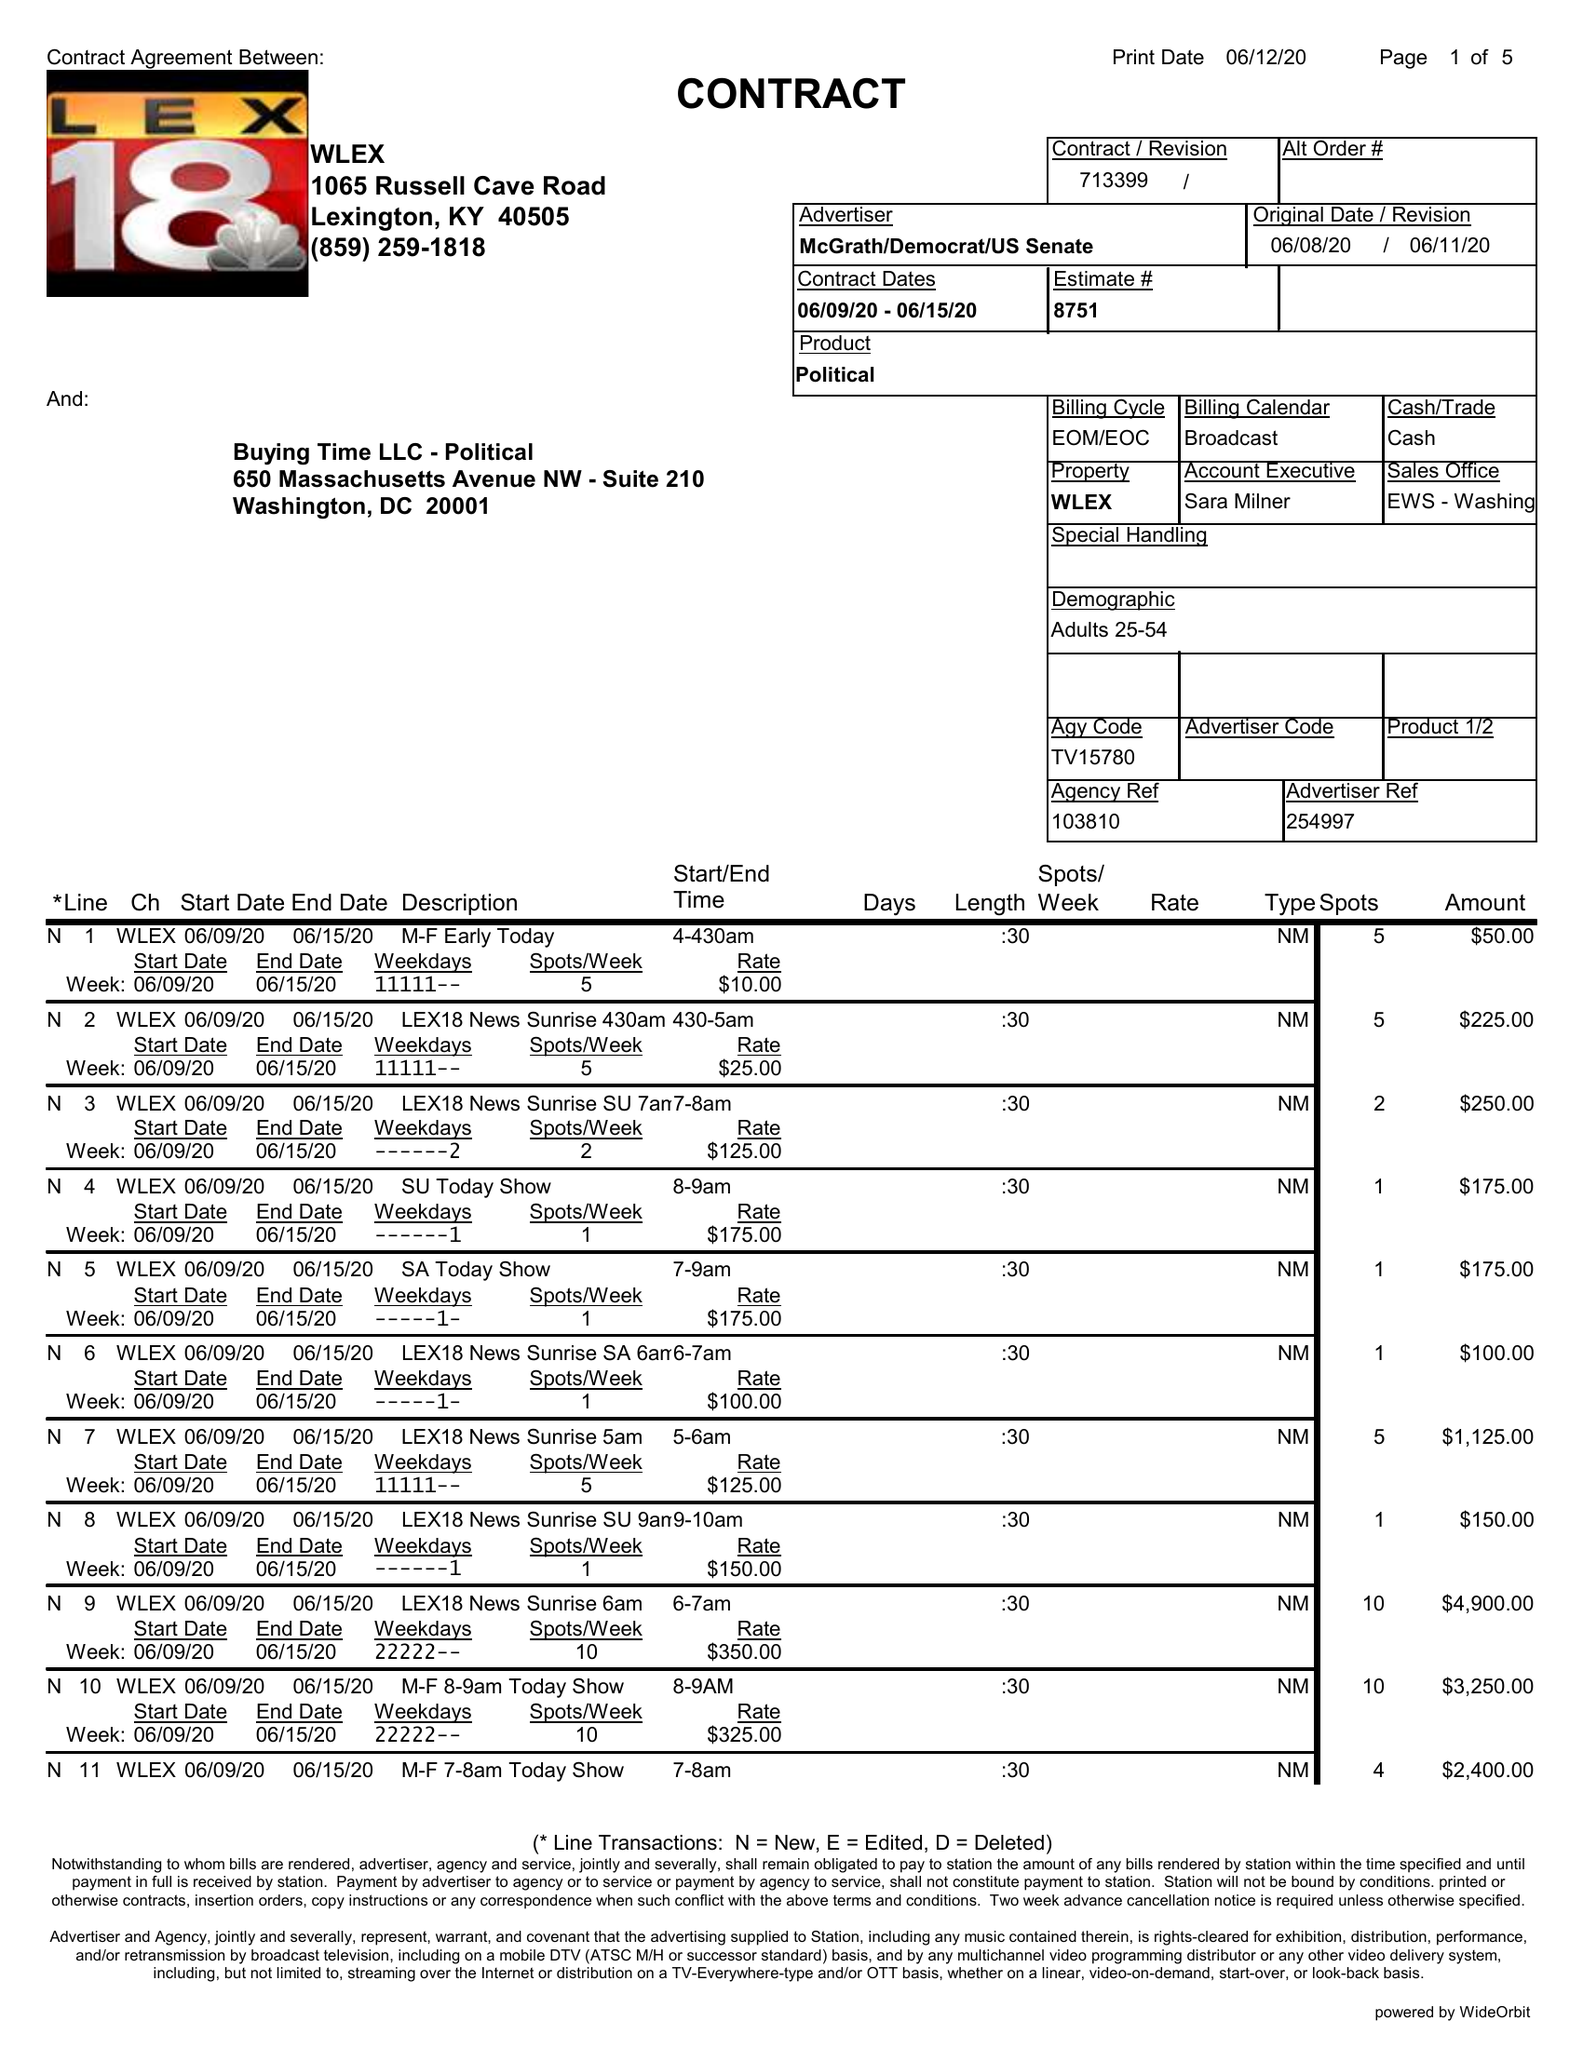What is the value for the advertiser?
Answer the question using a single word or phrase. MCGRATH/DEMOCRAT/USSENATE 